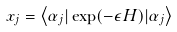Convert formula to latex. <formula><loc_0><loc_0><loc_500><loc_500>x _ { j } = \left \langle \alpha _ { j } | \exp ( - \epsilon H ) | \alpha _ { j } \right \rangle</formula> 